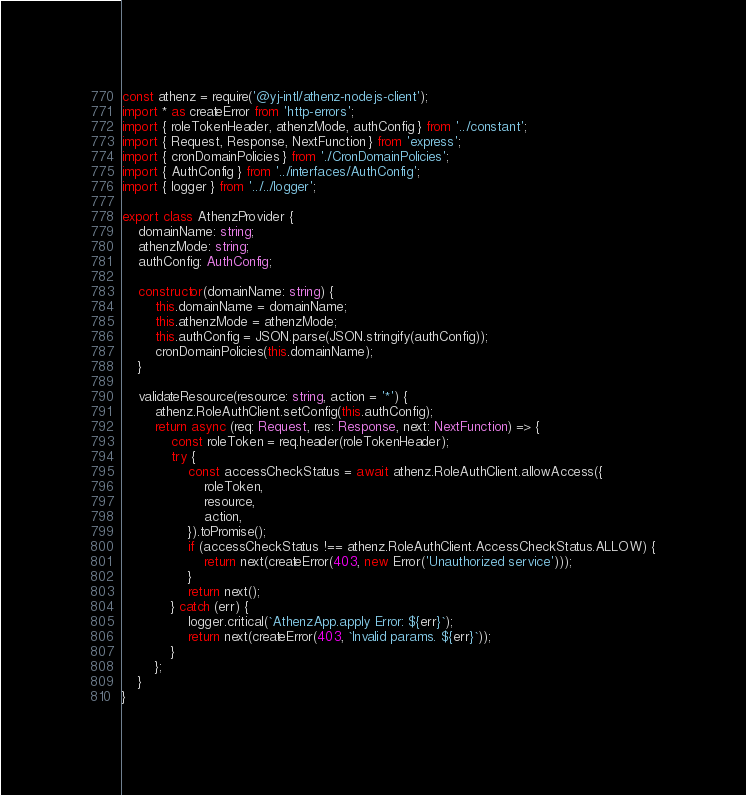<code> <loc_0><loc_0><loc_500><loc_500><_TypeScript_>const athenz = require('@yj-intl/athenz-nodejs-client');
import * as createError from 'http-errors';
import { roleTokenHeader, athenzMode, authConfig } from '../constant';
import { Request, Response, NextFunction } from 'express';
import { cronDomainPolicies } from './CronDomainPolicies';
import { AuthConfig } from '../interfaces/AuthConfig';
import { logger } from '../../logger';

export class AthenzProvider {
    domainName: string;
    athenzMode: string;
    authConfig: AuthConfig;

    constructor(domainName: string) {
        this.domainName = domainName;
        this.athenzMode = athenzMode;
        this.authConfig = JSON.parse(JSON.stringify(authConfig));
        cronDomainPolicies(this.domainName);
    }

    validateResource(resource: string, action = '*') {
        athenz.RoleAuthClient.setConfig(this.authConfig);
        return async (req: Request, res: Response, next: NextFunction) => {
            const roleToken = req.header(roleTokenHeader);
            try {
                const accessCheckStatus = await athenz.RoleAuthClient.allowAccess({
                    roleToken,
                    resource,
                    action,
                }).toPromise();
                if (accessCheckStatus !== athenz.RoleAuthClient.AccessCheckStatus.ALLOW) {
                    return next(createError(403, new Error('Unauthorized service')));
                }
                return next();
            } catch (err) {
                logger.critical(`AthenzApp.apply Error: ${err}`);
                return next(createError(403, `Invalid params. ${err}`));
            }
        };
    }
}</code> 